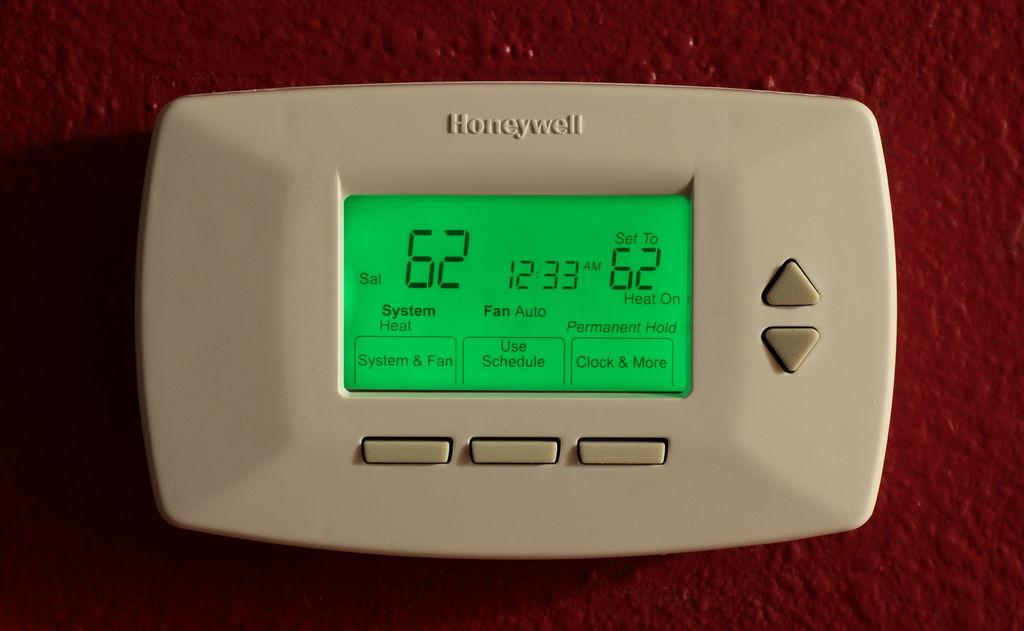Provide a one-sentence caption for the provided image. A rectangular device with Honeywell written on the top. 